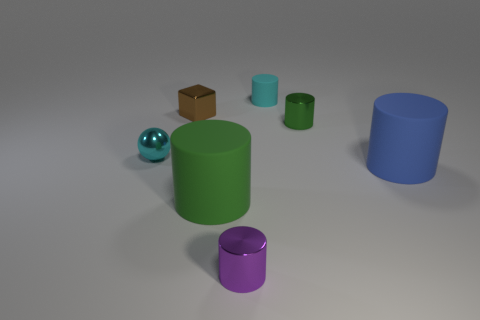Is the purple object the same shape as the brown thing?
Keep it short and to the point. No. What number of things are either cylinders or cylinders behind the tiny brown metallic block?
Offer a very short reply. 5. What is the material of the ball that is the same color as the tiny matte cylinder?
Keep it short and to the point. Metal. There is a shiny object on the left side of the brown shiny object; is its size the same as the green matte thing?
Provide a short and direct response. No. What number of green rubber cylinders are behind the metal cylinder that is to the left of the tiny matte object behind the small cyan metallic sphere?
Your response must be concise. 1. What number of cyan objects are small cylinders or shiny balls?
Provide a short and direct response. 2. What color is the tiny ball that is the same material as the small cube?
Provide a short and direct response. Cyan. Is there any other thing that has the same size as the cyan cylinder?
Your answer should be very brief. Yes. How many small things are shiny objects or green rubber objects?
Offer a very short reply. 4. Are there fewer tiny yellow rubber objects than brown objects?
Provide a succinct answer. Yes. 